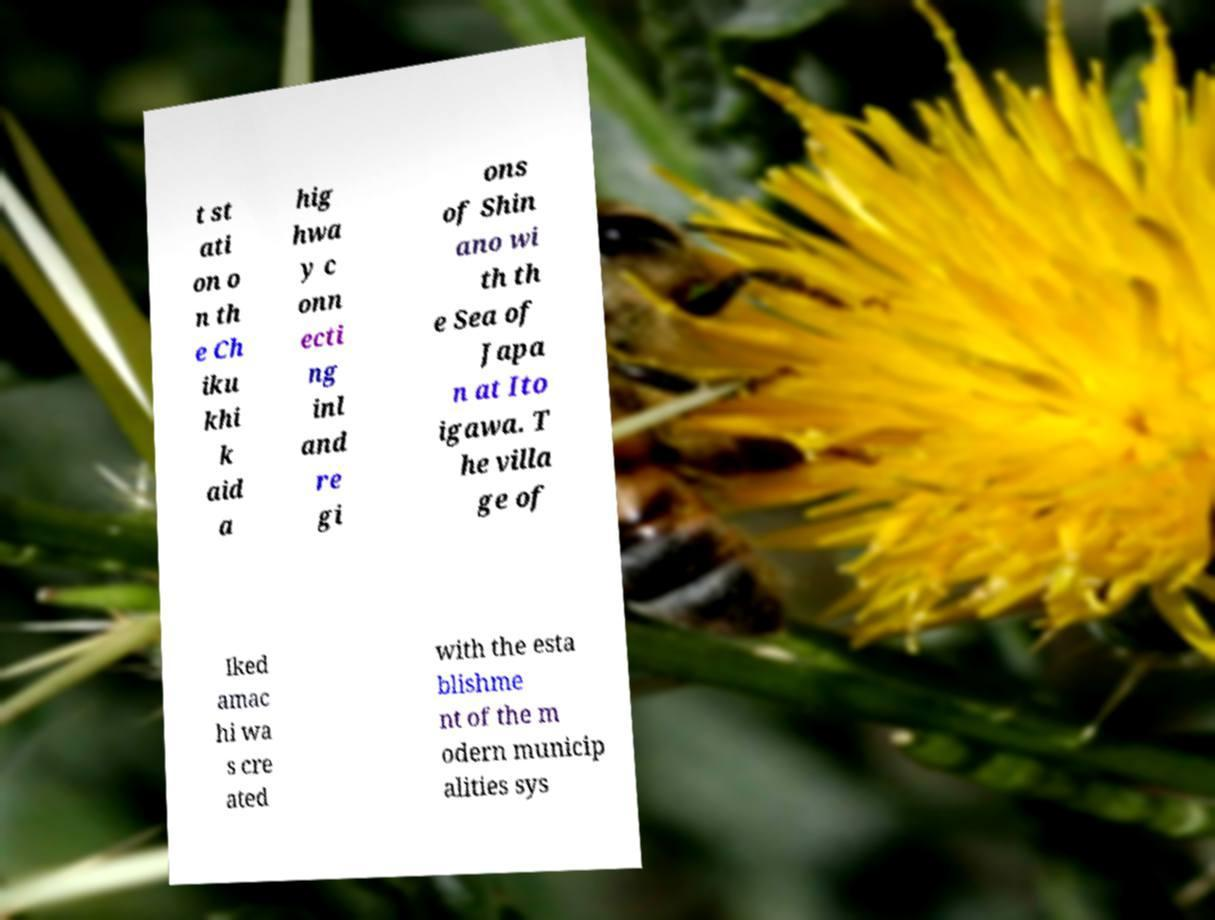Could you assist in decoding the text presented in this image and type it out clearly? t st ati on o n th e Ch iku khi k aid a hig hwa y c onn ecti ng inl and re gi ons of Shin ano wi th th e Sea of Japa n at Ito igawa. T he villa ge of Iked amac hi wa s cre ated with the esta blishme nt of the m odern municip alities sys 